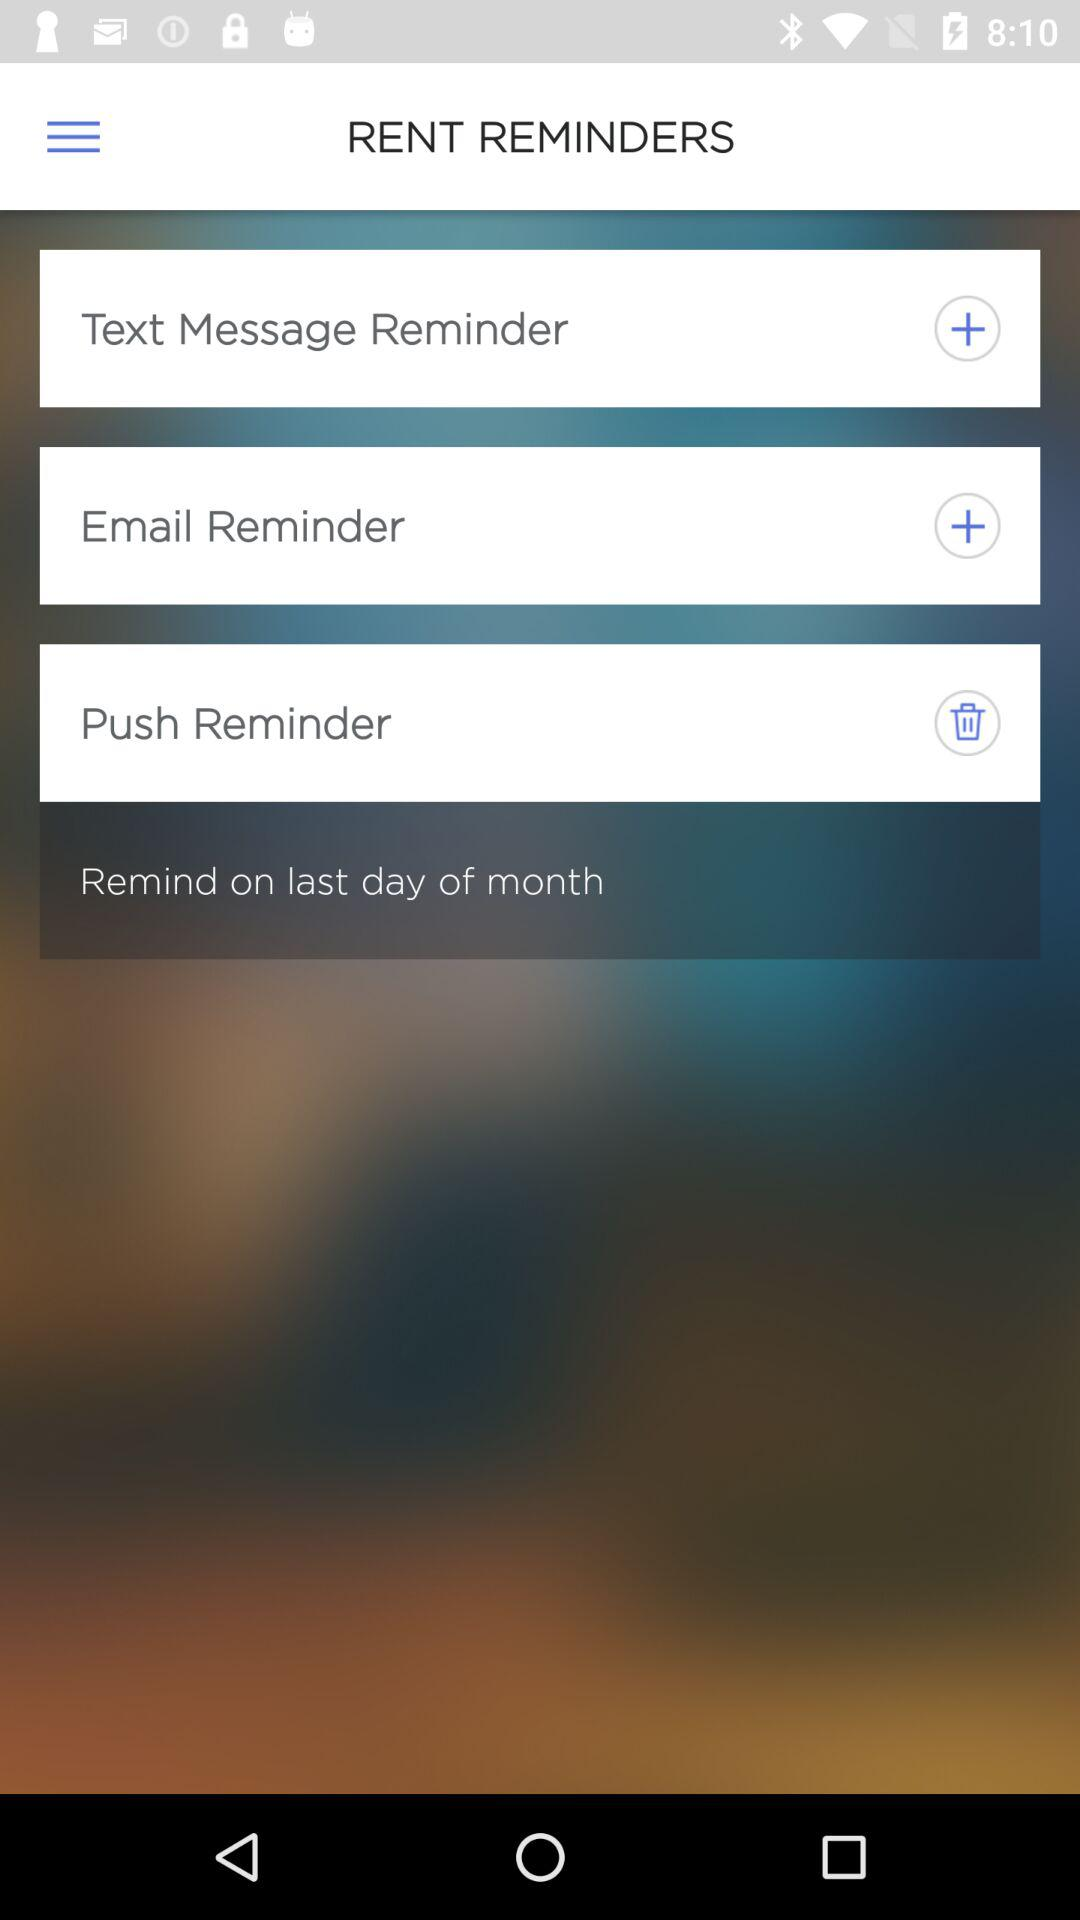For which day of the month is the reminder set for the rent? The reminder is set for the last day of the month. 